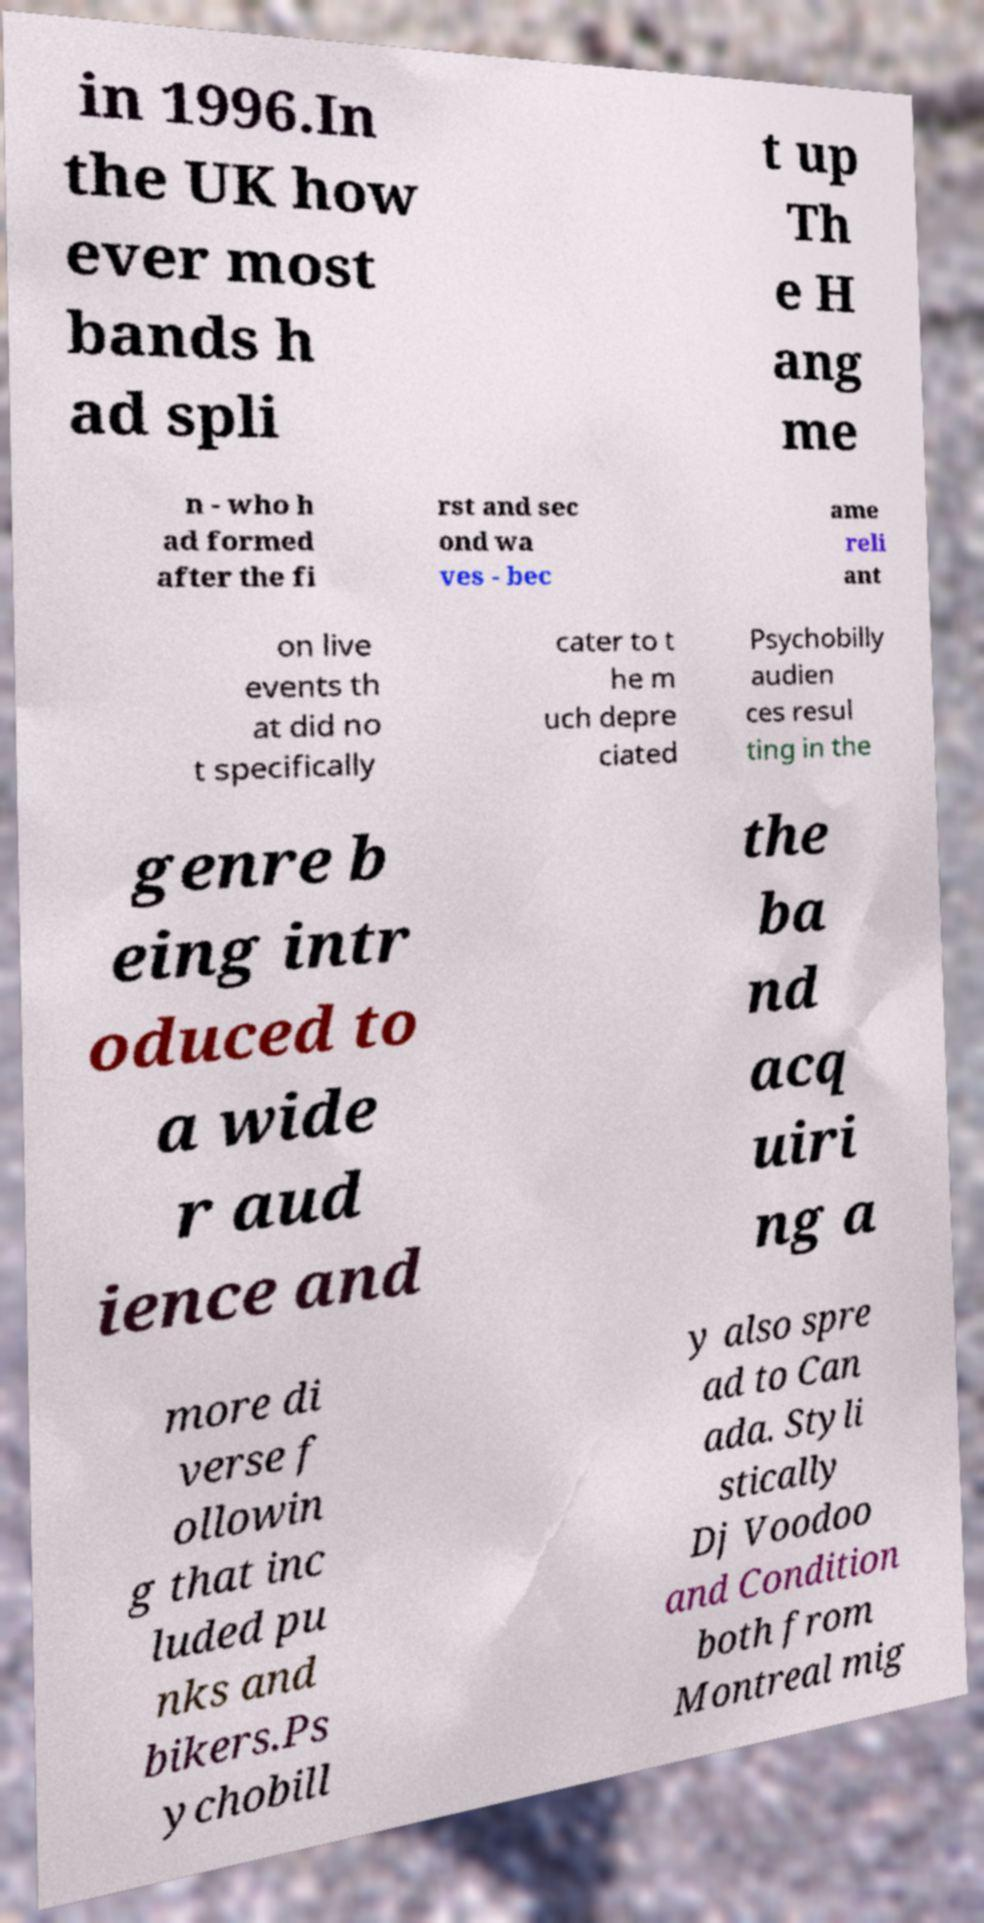Please read and relay the text visible in this image. What does it say? in 1996.In the UK how ever most bands h ad spli t up Th e H ang me n - who h ad formed after the fi rst and sec ond wa ves - bec ame reli ant on live events th at did no t specifically cater to t he m uch depre ciated Psychobilly audien ces resul ting in the genre b eing intr oduced to a wide r aud ience and the ba nd acq uiri ng a more di verse f ollowin g that inc luded pu nks and bikers.Ps ychobill y also spre ad to Can ada. Styli stically Dj Voodoo and Condition both from Montreal mig 